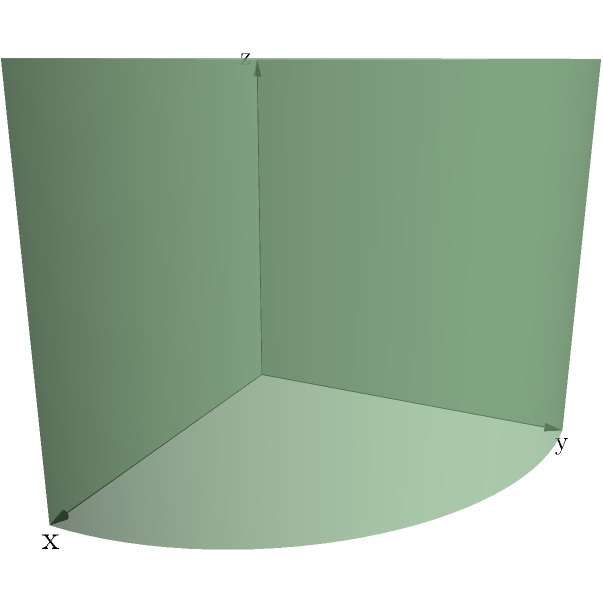Consider the surface formed by extruding the silhouette of Pac-Man (a classic arcade game character) along the z-axis, as shown in the figure. What is the genus of this surface? To determine the genus of the surface, we'll follow these steps:

1) First, recall that the genus of a surface is the maximum number of simple closed curves that can be drawn on the surface without separating it.

2) The extruded Pac-Man shape forms a solid cylinder with a "slice" removed.

3) Topologically, this shape is equivalent to a solid sphere with a tunnel through it. The tunnel is formed by the missing "slice" of the cylinder.

4) A sphere has genus 0, but adding a tunnel increases the genus by 1.

5) We can draw one simple closed curve around this tunnel without separating the surface.

6) Any additional closed curve would either be equivalent to this one or would separate the surface.

Therefore, the genus of this surface is 1.
Answer: 1 